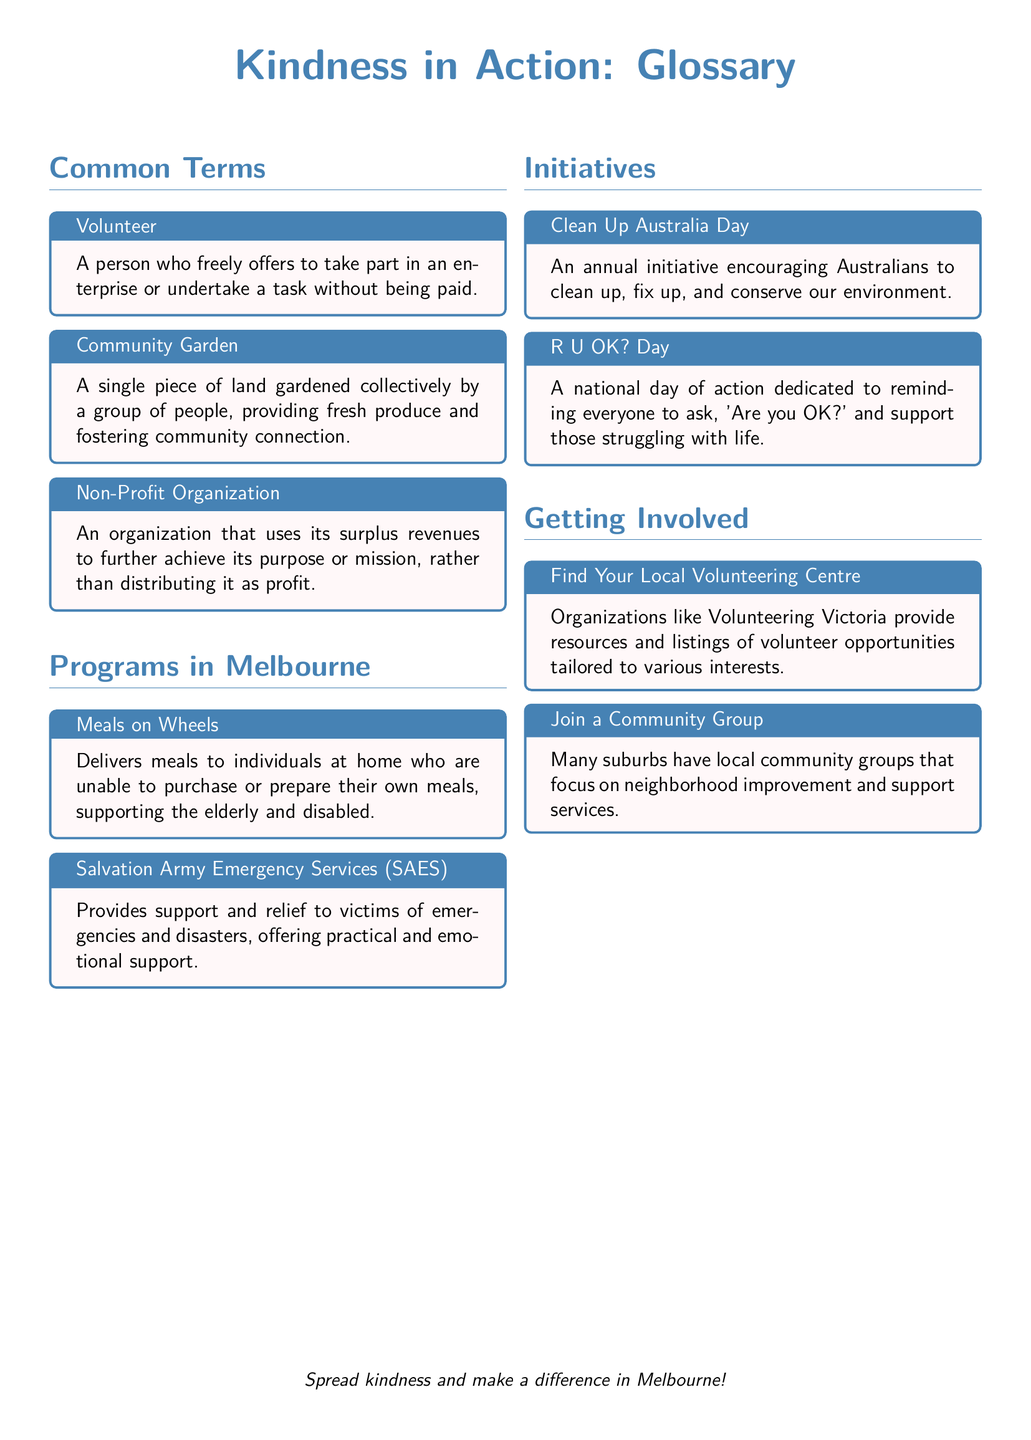what is a volunteer? A volunteer is defined in the document as a person who freely offers to take part in an enterprise or undertake a task without being paid.
Answer: a person who freely offers to take part in an enterprise or undertake a task without being paid what does Meals on Wheels provide? The document states that Meals on Wheels delivers meals to individuals at home who are unable to purchase or prepare their own meals.
Answer: meals to individuals at home what is R U OK? Day? According to the document, R U OK? Day is a national day of action dedicated to reminding everyone to ask, 'Are you OK?' and support those struggling with life.
Answer: a national day of action how many programs are listed in the document? The document lists a total of three programs under the Programs in Melbourne section.
Answer: three how can I find local volunteering opportunities? The document suggests that organizations like Volunteering Victoria provide resources and listings of volunteer opportunities tailored to various interests.
Answer: Volunteering Victoria what type of organization is a non-profit organization? The document defines a non-profit organization as an organization that uses its surplus revenues to further achieve its purpose or mission, rather than distributing it as profit.
Answer: an organization that uses its surplus revenues to further achieve its purpose or mission what initiative encourages Australians to clean up the environment? According to the document, Clean Up Australia Day encourages Australians to clean up, fix up, and conserve our environment.
Answer: Clean Up Australia Day which section of the document provides details on getting involved in volunteering? The details on getting involved in volunteering can be found in the Getting Involved section of the document.
Answer: Getting Involved 